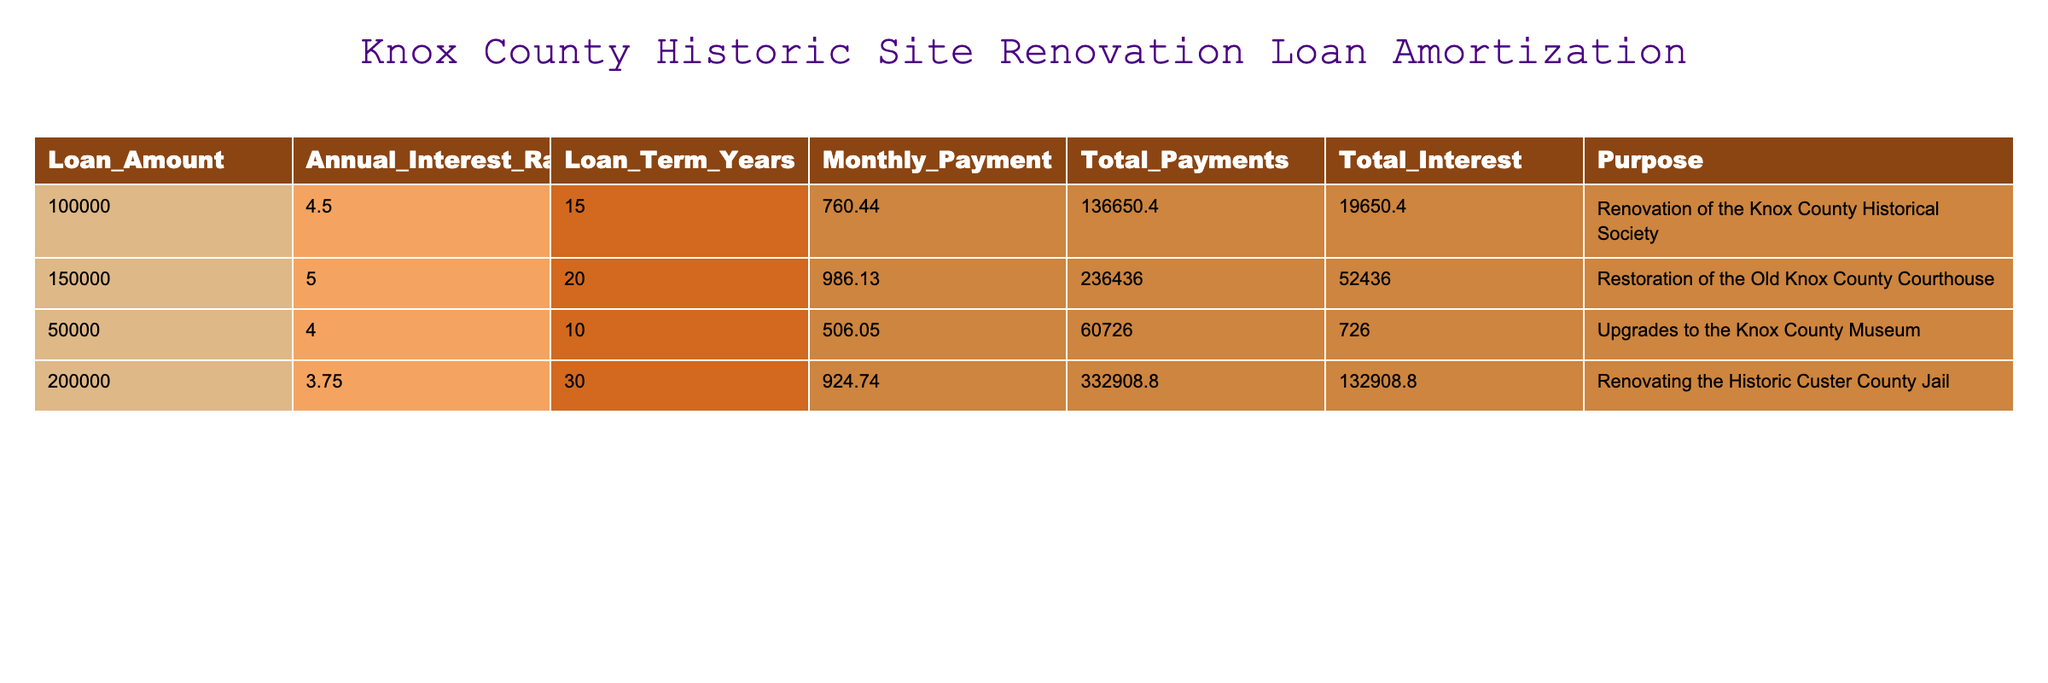What is the monthly payment for the renovation of the Knox County Historical Society? The table lists the loan details, and under the "Monthly_Payment" column for the Knox County Historical Society loan, the value is 760.44.
Answer: 760.44 What is the total interest paid on the restoration of the Old Knox County Courthouse? The total interest paid for the Old Knox County Courthouse loan is shown in the "Total_Interest" column, which is 52436.00.
Answer: 52436.00 How much more total interest will be paid on the renovation of the Historic Custer County Jail compared to the upgrades to the Knox County Museum? The total interest for the Historic Custer County Jail is 132908.80 and for the Knox County Museum, it is 726.00. The difference is 132908.80 - 726.00 = 132182.80.
Answer: 132182.80 Is the monthly payment for the upgrades to the Knox County Museum less than the monthly payment for the renovation of the Knox County Historical Society? The monthly payment for the Knox County Museum is 506.05, while for the Knox County Historical Society it is 760.44. Since 506.05 is less than 760.44, the answer is yes.
Answer: Yes What is the total payment made by the Knox County Museum over the entire loan period? The total payment is listed in the "Total_Payments" column for the Knox County Museum, which is 60726.00. This is the complete amount paid over the loan term.
Answer: 60726.00 Which loan has the highest monthly payment, and what is that amount? By reviewing the "Monthly_Payment" column, the highest monthly payment is for the restoration of the Old Knox County Courthouse at 986.13.
Answer: 986.13 What is the average loan amount for the projects listed in the table? The total loan amounts are 100000 + 150000 + 50000 + 200000 = 500000. There are 4 loans, so the average is 500000 / 4 = 125000.
Answer: 125000 If we look at the total payments, which renovation project has the lowest total payment? The total payments for each project can be compared: 136650.40 for the Knox County Historical Society, 236436.00 for the Old Knox County Courthouse, 60726.00 for the Knox County Museum, and 332908.80 for the Historic Custer County Jail. The lowest is 60726.00 for the Knox County Museum.
Answer: 60726.00 What is the difference in loan term years between the renovation of the Knox County Historical Society and the restoration of the Old Knox County Courthouse? The loan term for the Knox County Historical Society is 15 years and for the Old Knox County Courthouse is 20 years. The difference is 20 - 15 = 5 years.
Answer: 5 years 